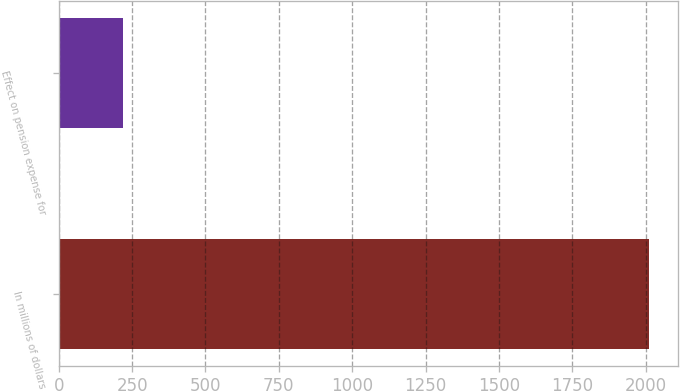Convert chart. <chart><loc_0><loc_0><loc_500><loc_500><bar_chart><fcel>In millions of dollars<fcel>Effect on pension expense for<nl><fcel>2010<fcel>218.1<nl></chart> 